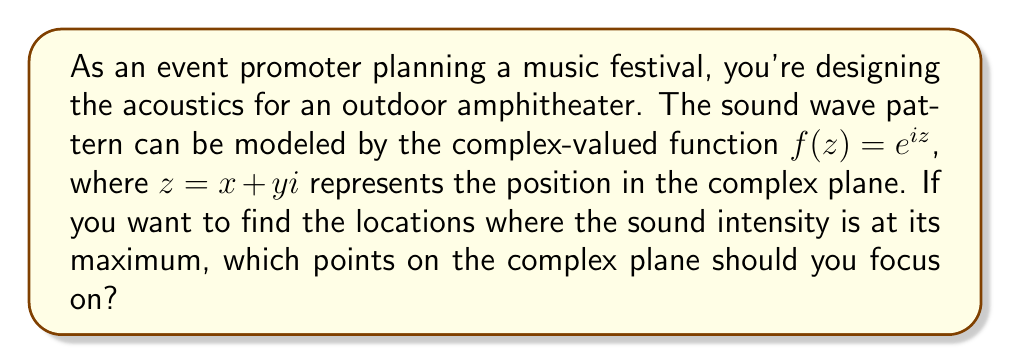Provide a solution to this math problem. To solve this problem, we need to understand the relationship between complex analysis and sound wave patterns:

1) The function $f(z) = e^{iz}$ is a complex exponential function that represents a plane wave. In acoustics, this can model a simple harmonic sound wave.

2) The magnitude of a complex number represents the amplitude of the wave, which is directly related to the sound intensity.

3) For $f(z) = e^{iz}$, we can use Euler's formula:

   $e^{iz} = \cos(z) + i\sin(z)$

4) The magnitude of this function is:

   $|f(z)| = |e^{iz}| = \sqrt{(\cos(z))^2 + (\sin(z))^2} = 1$

5) This means that the magnitude is constant for all $z$. However, the phase of the wave changes with $z$.

6) The phase is given by the argument of the complex number:

   $\arg(f(z)) = \arg(e^{iz}) = z \mod 2\pi$

7) The sound intensity is maximum where waves constructively interfere, which occurs when the phase difference is a multiple of $2\pi$.

8) This happens when $z$ is a real multiple of $2\pi$, i.e., when $z = 2\pi n$, where $n$ is any integer.

9) In the complex plane, these points lie on the real axis at intervals of $2\pi$.

Therefore, the sound intensity is maximum at points $z = 2\pi n$ on the real axis of the complex plane, where $n$ is any integer.
Answer: The sound intensity is maximum at points $z = 2\pi n$ on the real axis of the complex plane, where $n$ is any integer. 